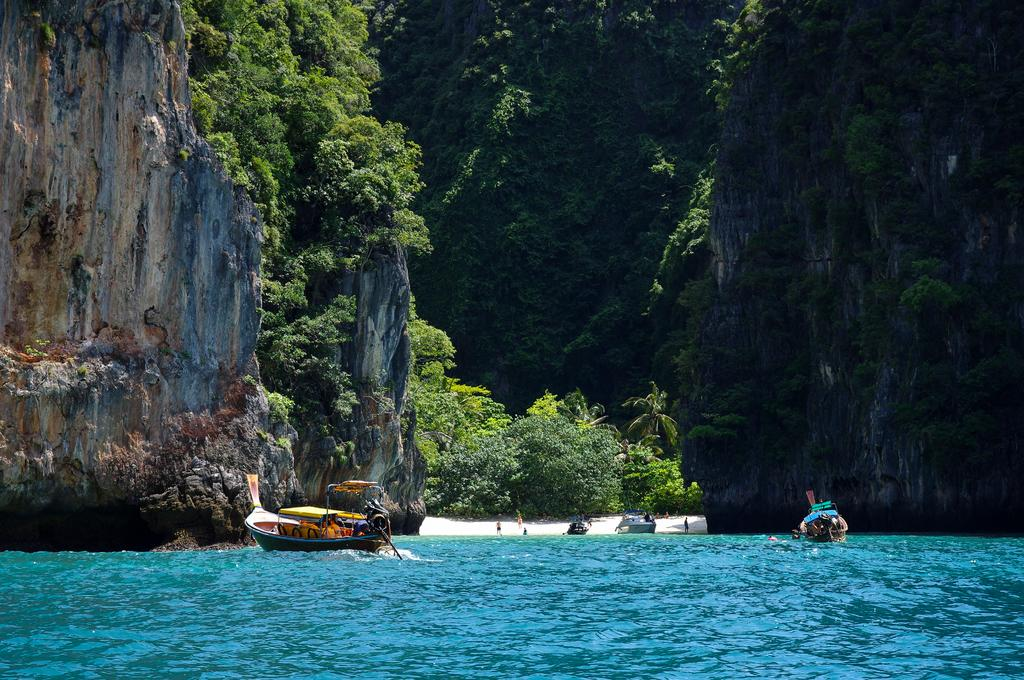What is the primary element in the image? There is water in the image. What is present in the water? There are boats in the water. What can be seen in the background of the image? There are hills, people, and trees in the background of the image. What type of drain is visible in the image? There is no drain present in the image; it features water, boats, and a background with hills, people, and trees. 